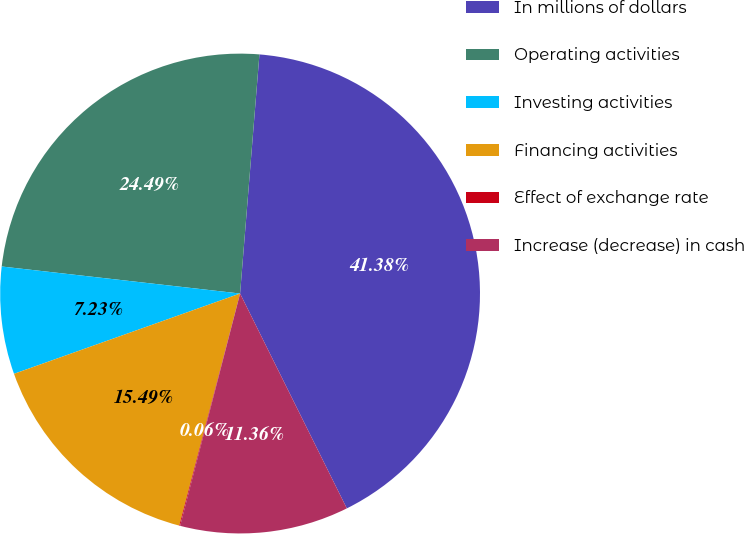Convert chart. <chart><loc_0><loc_0><loc_500><loc_500><pie_chart><fcel>In millions of dollars<fcel>Operating activities<fcel>Investing activities<fcel>Financing activities<fcel>Effect of exchange rate<fcel>Increase (decrease) in cash<nl><fcel>41.38%<fcel>24.49%<fcel>7.23%<fcel>15.49%<fcel>0.06%<fcel>11.36%<nl></chart> 